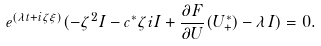<formula> <loc_0><loc_0><loc_500><loc_500>e ^ { ( \lambda t + i \zeta \xi ) } ( - \zeta ^ { 2 } I - c ^ { * } \zeta i I + \frac { \partial F } { \partial U } ( U _ { + } ^ { * } ) - \lambda I ) = 0 .</formula> 